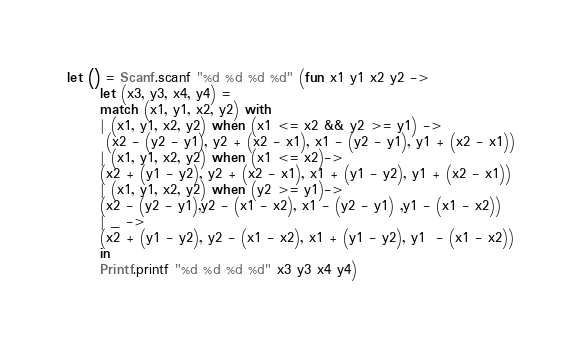<code> <loc_0><loc_0><loc_500><loc_500><_OCaml_>let () = Scanf.scanf "%d %d %d %d" (fun x1 y1 x2 y2 ->
      let (x3, y3, x4, y4) = 
      match (x1, y1, x2, y2) with
      | (x1, y1, x2, y2) when (x1 <= x2 && y2 >= y1) ->
       (x2 - (y2 - y1), y2 + (x2 - x1), x1 - (y2 - y1), y1 + (x2 - x1))
      | (x1, y1, x2, y2) when (x1 <= x2)-> 
      (x2 + (y1 - y2), y2 + (x2 - x1), x1 + (y1 - y2), y1 + (x2 - x1))
      | (x1, y1, x2, y2) when (y2 >= y1)->  
      (x2 - (y2 - y1),y2 - (x1 - x2), x1 - (y2 - y1) ,y1 - (x1 - x2))
      | _ -> 
      (x2 + (y1 - y2), y2 - (x1 - x2), x1 + (y1 - y2), y1  - (x1 - x2))
      in
      Printf.printf "%d %d %d %d" x3 y3 x4 y4)</code> 